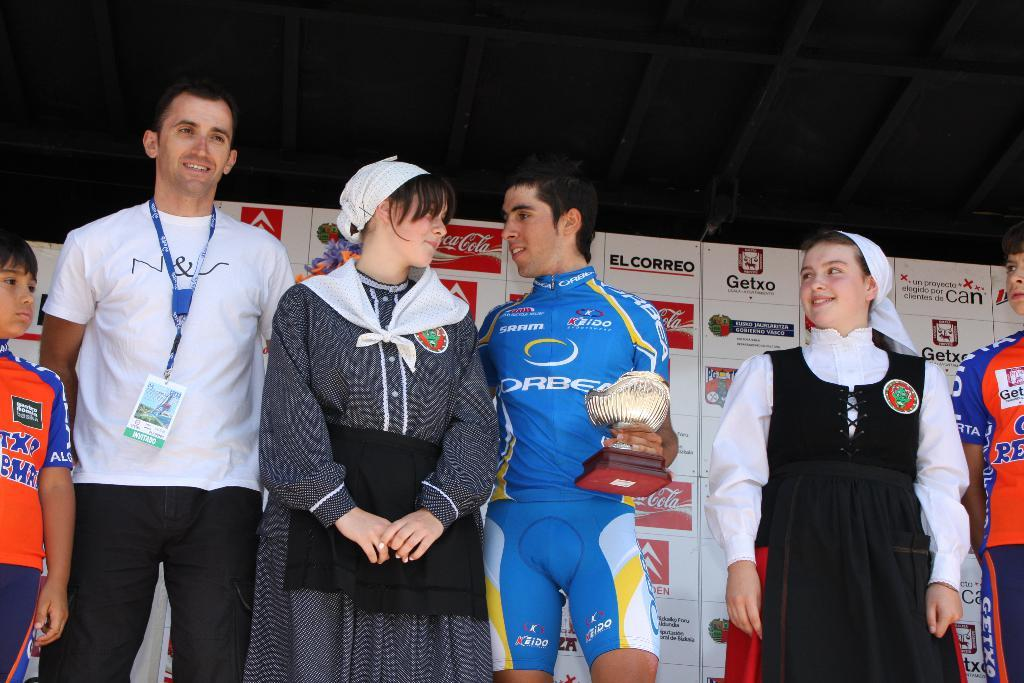<image>
Write a terse but informative summary of the picture. The winner get a trophy while the sponsors are displayed in the back, one of them being Coca-Cola. 